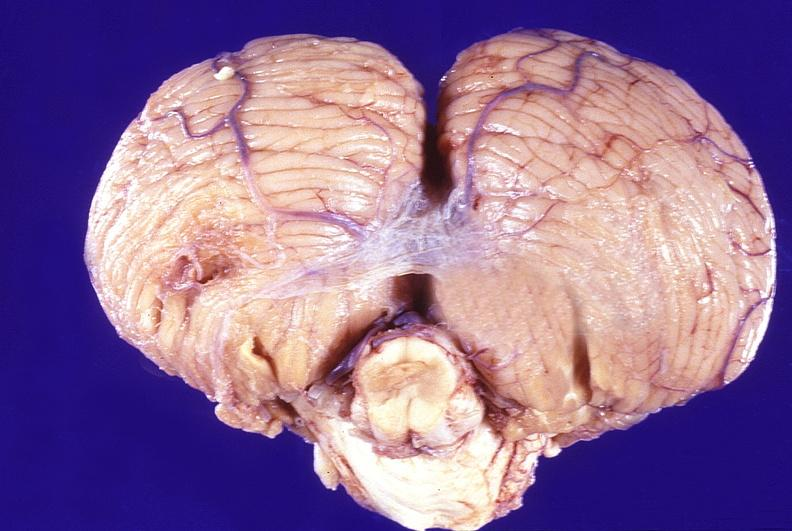s view of head with scalp present?
Answer the question using a single word or phrase. No 